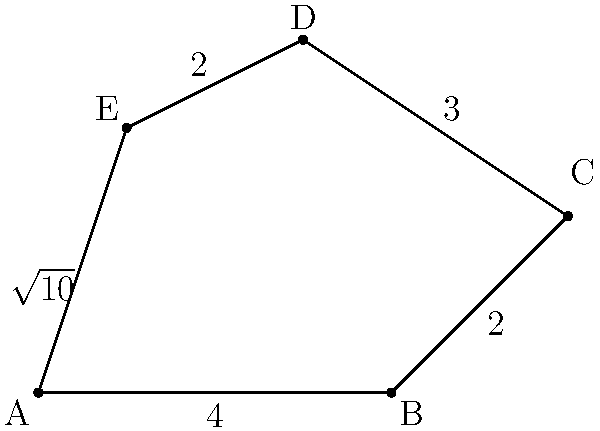In a land dispute case, you're presented with a property boundary described by the vertices of an irregular pentagon ABCDE. Given that the coordinates of the vertices are A(0,0), B(4,0), C(6,2), D(3,4), and E(1,3), calculate the perimeter of the property. Round your answer to two decimal places. To find the perimeter of the irregular pentagon, we need to calculate the distance between each pair of consecutive vertices and sum these distances. We can use the distance formula between two points: $d = \sqrt{(x_2-x_1)^2 + (y_2-y_1)^2}$.

1. Distance AB:
   $d_{AB} = \sqrt{(4-0)^2 + (0-0)^2} = 4$

2. Distance BC:
   $d_{BC} = \sqrt{(6-4)^2 + (2-0)^2} = \sqrt{4 + 4} = \sqrt{8} = 2\sqrt{2} \approx 2.83$

3. Distance CD:
   $d_{CD} = \sqrt{(3-6)^2 + (4-2)^2} = \sqrt{9 + 4} = \sqrt{13} \approx 3.61$

4. Distance DE:
   $d_{DE} = \sqrt{(1-3)^2 + (3-4)^2} = \sqrt{4 + 1} = \sqrt{5} \approx 2.24$

5. Distance EA:
   $d_{EA} = \sqrt{(0-1)^2 + (0-3)^2} = \sqrt{1 + 9} = \sqrt{10} \approx 3.16$

Sum of all distances:
$\text{Perimeter} = 4 + 2\sqrt{2} + \sqrt{13} + \sqrt{5} + \sqrt{10}$

Using a calculator and rounding to two decimal places:
$\text{Perimeter} \approx 4 + 2.83 + 3.61 + 2.24 + 3.16 = 15.84$
Answer: 15.84 units 